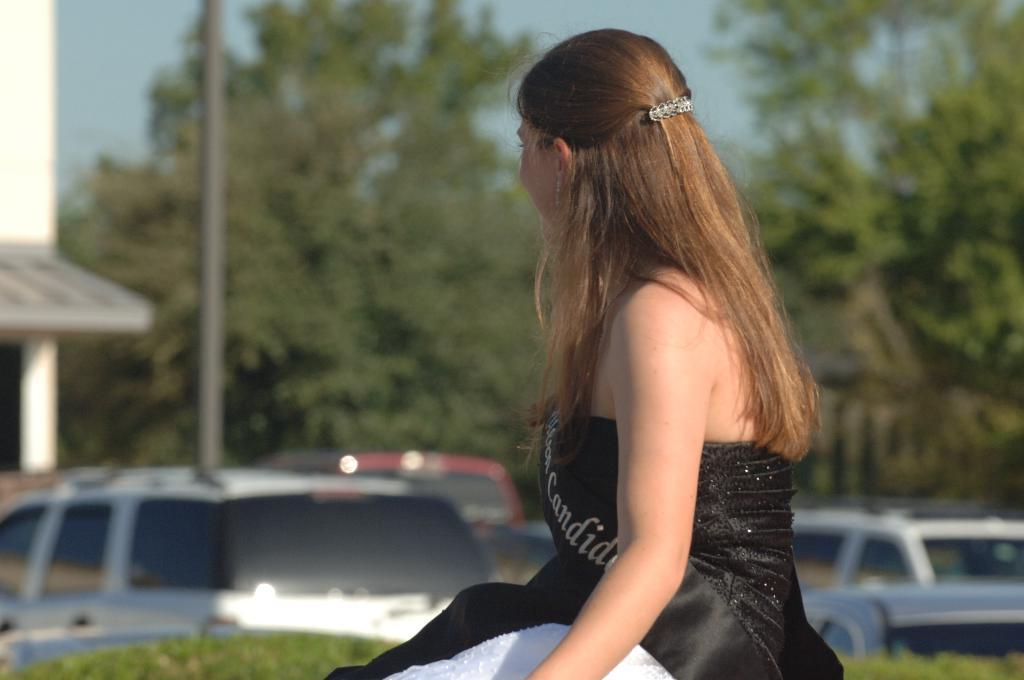What is the woman in the image doing? The woman is sitting in the image. What is the woman wearing? The woman is wearing a black dress. What can be seen in the background of the image? There are cars and trees in the background of the image. What is visible at the top of the image? The sky is visible at the top of the image. What type of lettuce is being used as a chin rest in the image? There is no lettuce or chin rest present in the image. What punishment is the woman receiving in the image? There is no indication of punishment in the image; the woman is simply sitting. 